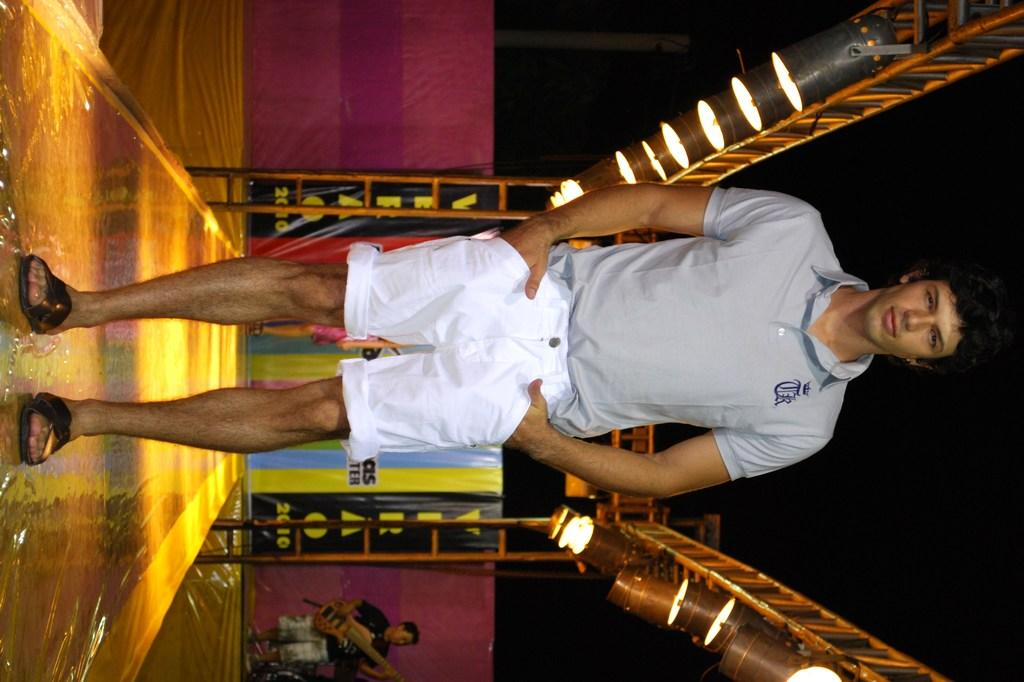What is the main subject of the image? There is a man standing in the image. What can be seen in the background of the image? There is a person holding an object in the background of the image. What type of lighting is present in the image? There are lights visible in the image. What kind of structure is present in the image? There is a metal frame in the image. What type of owl can be seen perched on the metal frame in the image? There is no owl present in the image; it only features a man, lights, and a metal frame. How does the person holding an object in the background control the lights in the image? The image does not show any control mechanism for the lights, and the person holding an object is not interacting with the lights. 